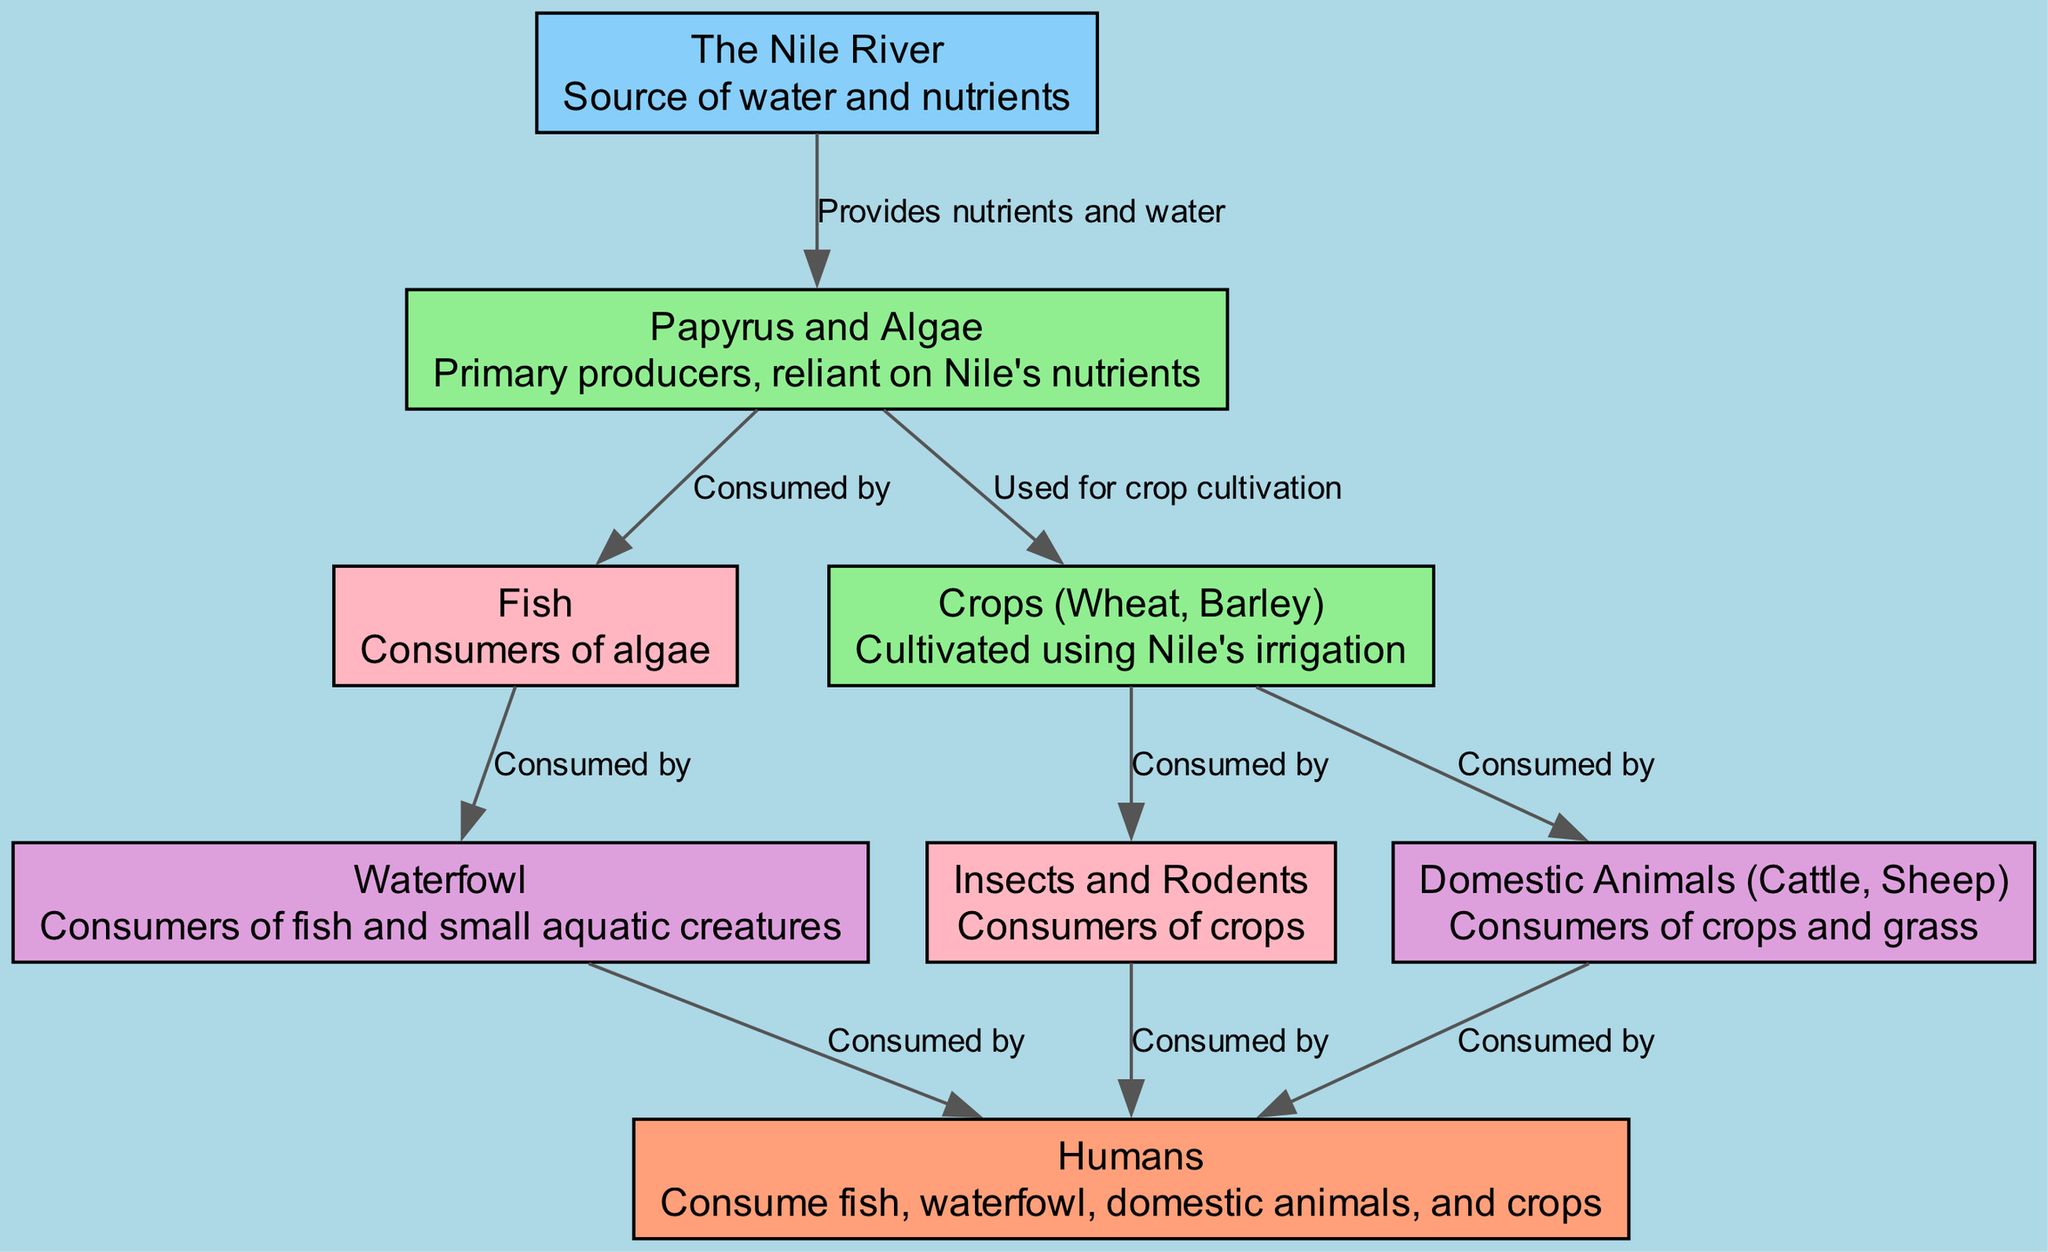What is the source of water and nutrients in the food chain? The diagram identifies “The Nile River” as the source of water and nutrients, which is a crucial element for the entire food chain.
Answer: The Nile River How many primary producers are shown in the diagram? The diagram displays two primary producers: "Papyrus and Algae" and "Crops (Wheat, Barley)," which rely on the Nile's nutrients for their growth.
Answer: Two What consumes the algae? According to the diagram, "Fish" is the entity that consumes algae, indicating a direct dietary relationship in the food chain.
Answer: Fish Which consumer is at the second trophic level? "Waterfowl" are at the second trophic level as they consume fish, which are primary consumers, indicating their position in the food chain.
Answer: Waterfowl What is directly consumed by humans? The diagram shows that humans consume multiple sources, including "Fish," "Waterfowl," "Domestic Animals," and "Crops," highlighting their varied diet.
Answer: Fish, Waterfowl, Domestic Animals, Crops Which organism is at the top of the food chain? The diagram illustrates that "Humans" are at the top of the food chain, consuming multiple organisms from lower levels, indicating their apex position.
Answer: Humans How does the Nile River affect crop cultivation? The diagram states that the Nile River is used for irrigation, providing the necessary water and nutrients for crops like wheat and barley to thrive.
Answer: Irrigation What is the role of insects and rodents in the food chain? In the diagram, insects and rodents are identified as consumers of crops, showing their role in linking the primary producers to higher trophic levels.
Answer: Consumers of crops 